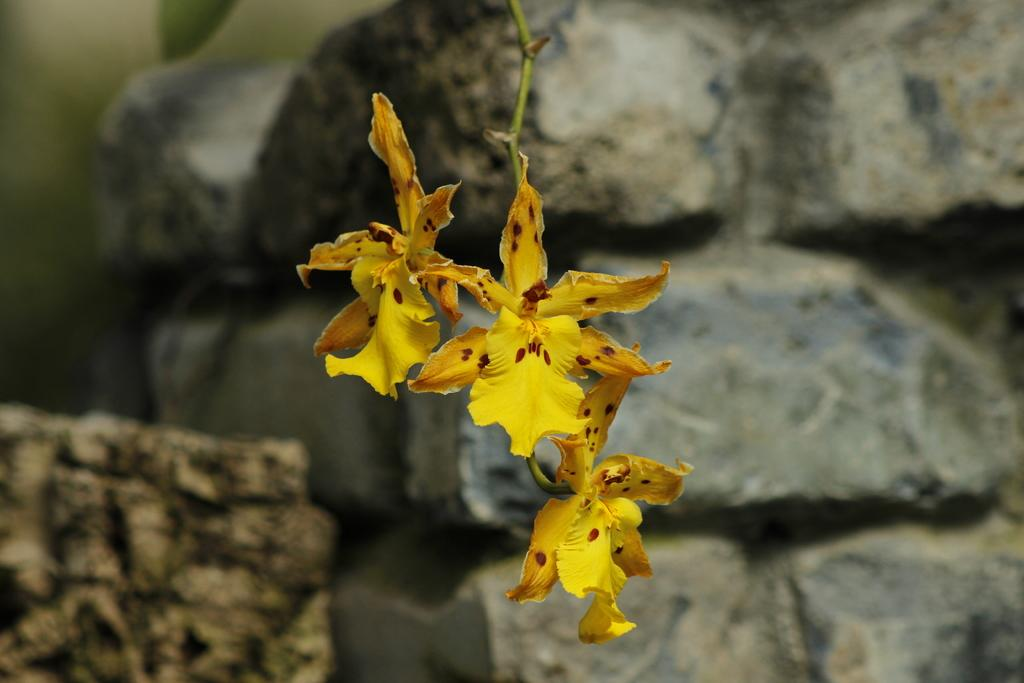What type of flowers can be seen on the plant in the image? There are yellow color flowers on a plant in the image. What can be seen in the background of the image? There is a wall in the background of the image. What type of engine can be seen powering the skate in the image? There is no engine or skate present in the image; it features yellow color flowers on a plant and a wall in the background. 